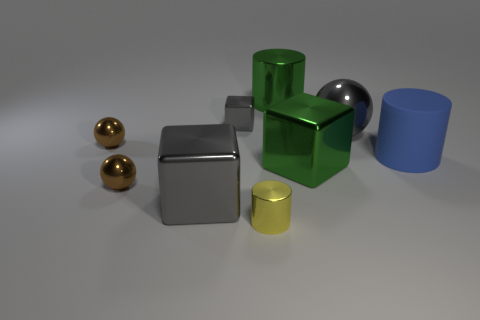How many tiny shiny cylinders are the same color as the big rubber cylinder?
Give a very brief answer. 0. The big green thing in front of the green metallic object that is behind the blue matte object is what shape?
Make the answer very short. Cube. What number of small gray blocks have the same material as the large blue thing?
Your response must be concise. 0. What is the thing right of the gray shiny sphere made of?
Your response must be concise. Rubber. What is the shape of the big gray object behind the brown metallic ball that is to the left of the ball in front of the large blue cylinder?
Your answer should be very brief. Sphere. There is a big block that is to the left of the small gray block; does it have the same color as the tiny metal cube that is on the left side of the tiny shiny cylinder?
Offer a terse response. Yes. Is the number of tiny spheres behind the large gray metallic sphere less than the number of big gray things that are to the left of the small gray shiny thing?
Ensure brevity in your answer.  Yes. Are there any other things that are the same shape as the matte object?
Provide a succinct answer. Yes. There is a tiny thing that is the same shape as the big blue thing; what color is it?
Offer a very short reply. Yellow. Is the shape of the big rubber thing the same as the big gray shiny thing that is on the right side of the yellow shiny thing?
Make the answer very short. No. 